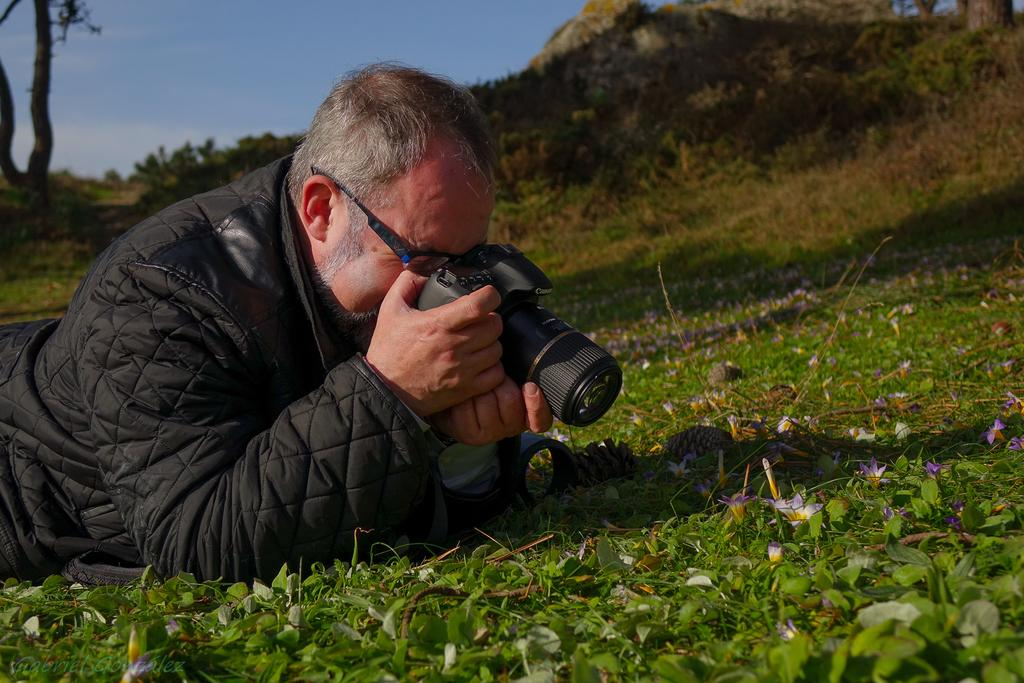What is the person in the image doing? The person is lying on the grass in the image. What is the person wearing? The person is wearing a jacket and spectacles. What object is the person holding? The person is holding a camera. What can be seen in the distance in the image? There are plants and trees in the distance. What type of attraction can be seen in the image? There is no attraction present in the image; it features a person lying on the grass, wearing a jacket and spectacles, holding a camera, and surrounded by plants and trees in the distance. How many ladybugs are visible on the person's jacket in the image? There are no ladybugs visible on the person's jacket in the image. 